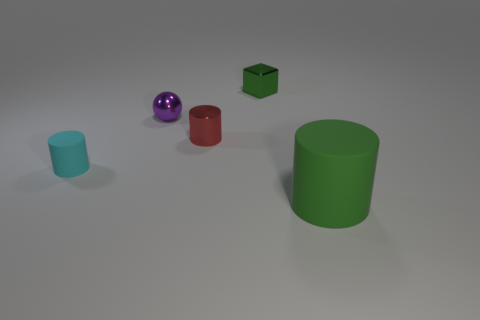There is a matte thing to the left of the green object that is left of the green rubber cylinder; what number of large green rubber cylinders are behind it?
Your answer should be very brief. 0. How many shiny things are both in front of the purple thing and left of the tiny shiny cylinder?
Offer a terse response. 0. The matte thing that is the same color as the small metallic cube is what shape?
Give a very brief answer. Cylinder. Do the tiny cyan cylinder and the red cylinder have the same material?
Offer a very short reply. No. The green object that is to the left of the matte cylinder right of the red object that is on the right side of the tiny purple metal sphere is what shape?
Your answer should be compact. Cube. Is the number of small red objects to the left of the purple sphere less than the number of tiny objects that are behind the cyan matte cylinder?
Keep it short and to the point. Yes. There is a green object on the left side of the matte cylinder that is on the right side of the tiny cube; what is its shape?
Your answer should be very brief. Cube. Are there any other things that are the same color as the small metal cylinder?
Offer a very short reply. No. Do the large thing and the cube have the same color?
Provide a short and direct response. Yes. How many green objects are either tiny rubber cylinders or large matte cylinders?
Offer a very short reply. 1. 